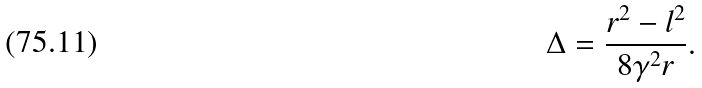Convert formula to latex. <formula><loc_0><loc_0><loc_500><loc_500>\Delta = \frac { r ^ { 2 } - l ^ { 2 } } { 8 \gamma ^ { 2 } r } .</formula> 